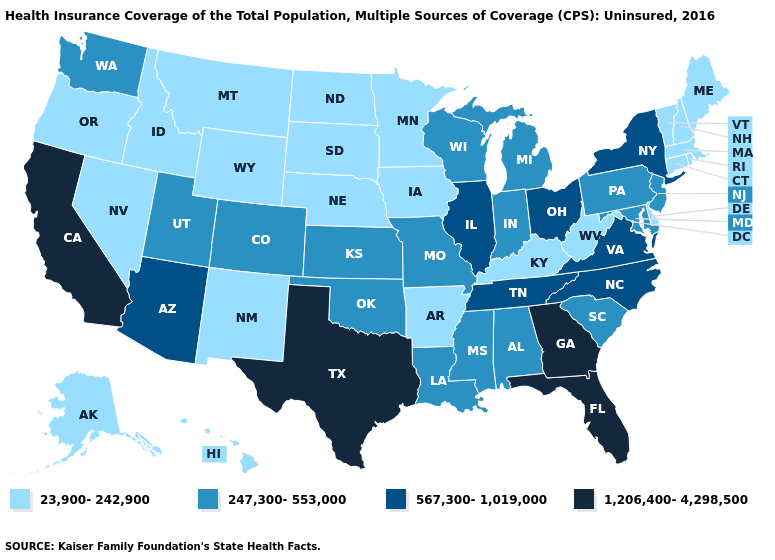Is the legend a continuous bar?
Quick response, please. No. Name the states that have a value in the range 567,300-1,019,000?
Concise answer only. Arizona, Illinois, New York, North Carolina, Ohio, Tennessee, Virginia. What is the value of Arkansas?
Write a very short answer. 23,900-242,900. What is the lowest value in the West?
Quick response, please. 23,900-242,900. Name the states that have a value in the range 567,300-1,019,000?
Write a very short answer. Arizona, Illinois, New York, North Carolina, Ohio, Tennessee, Virginia. Which states have the highest value in the USA?
Write a very short answer. California, Florida, Georgia, Texas. What is the highest value in states that border Ohio?
Keep it brief. 247,300-553,000. Name the states that have a value in the range 23,900-242,900?
Short answer required. Alaska, Arkansas, Connecticut, Delaware, Hawaii, Idaho, Iowa, Kentucky, Maine, Massachusetts, Minnesota, Montana, Nebraska, Nevada, New Hampshire, New Mexico, North Dakota, Oregon, Rhode Island, South Dakota, Vermont, West Virginia, Wyoming. Name the states that have a value in the range 567,300-1,019,000?
Quick response, please. Arizona, Illinois, New York, North Carolina, Ohio, Tennessee, Virginia. Name the states that have a value in the range 23,900-242,900?
Short answer required. Alaska, Arkansas, Connecticut, Delaware, Hawaii, Idaho, Iowa, Kentucky, Maine, Massachusetts, Minnesota, Montana, Nebraska, Nevada, New Hampshire, New Mexico, North Dakota, Oregon, Rhode Island, South Dakota, Vermont, West Virginia, Wyoming. Does Missouri have the highest value in the USA?
Give a very brief answer. No. Name the states that have a value in the range 247,300-553,000?
Quick response, please. Alabama, Colorado, Indiana, Kansas, Louisiana, Maryland, Michigan, Mississippi, Missouri, New Jersey, Oklahoma, Pennsylvania, South Carolina, Utah, Washington, Wisconsin. What is the value of Florida?
Keep it brief. 1,206,400-4,298,500. Does the map have missing data?
Short answer required. No. 